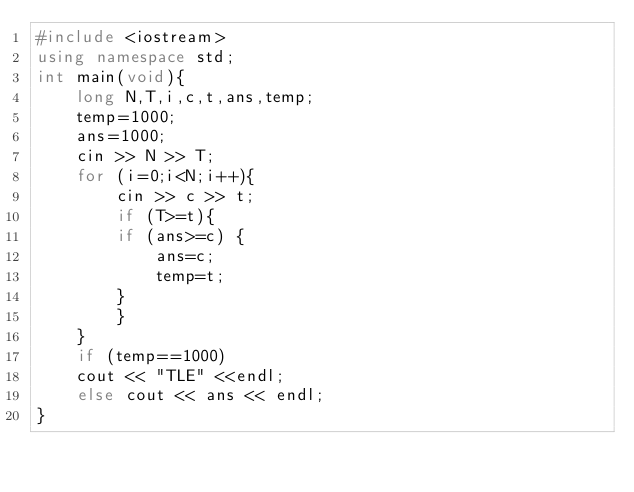<code> <loc_0><loc_0><loc_500><loc_500><_C++_>#include <iostream>
using namespace std;
int main(void){
    long N,T,i,c,t,ans,temp;
    temp=1000;
    ans=1000;
    cin >> N >> T;
    for (i=0;i<N;i++){
        cin >> c >> t;
        if (T>=t){
        if (ans>=c) {
            ans=c;
            temp=t;
        }
        }
    }
    if (temp==1000)
    cout << "TLE" <<endl;
    else cout << ans << endl;
}</code> 